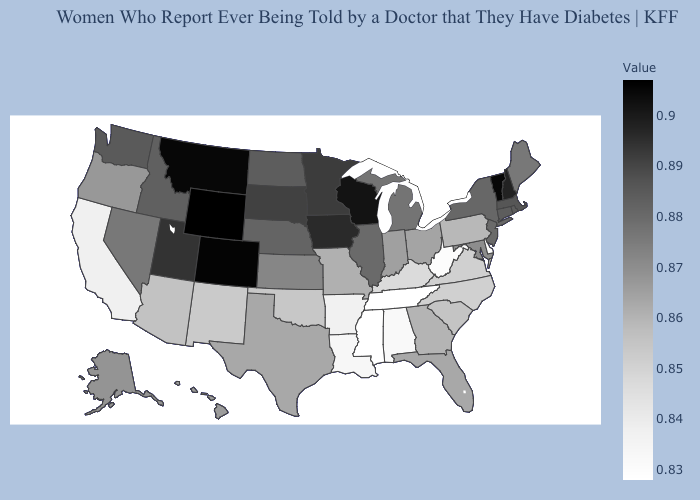Does Arizona have a higher value than Mississippi?
Short answer required. Yes. Does Nevada have a lower value than Iowa?
Answer briefly. Yes. Does Maryland have the highest value in the South?
Answer briefly. Yes. Does Nevada have the lowest value in the West?
Write a very short answer. No. Does California have the lowest value in the West?
Keep it brief. Yes. Does Texas have a lower value than Delaware?
Concise answer only. No. Is the legend a continuous bar?
Give a very brief answer. Yes. 